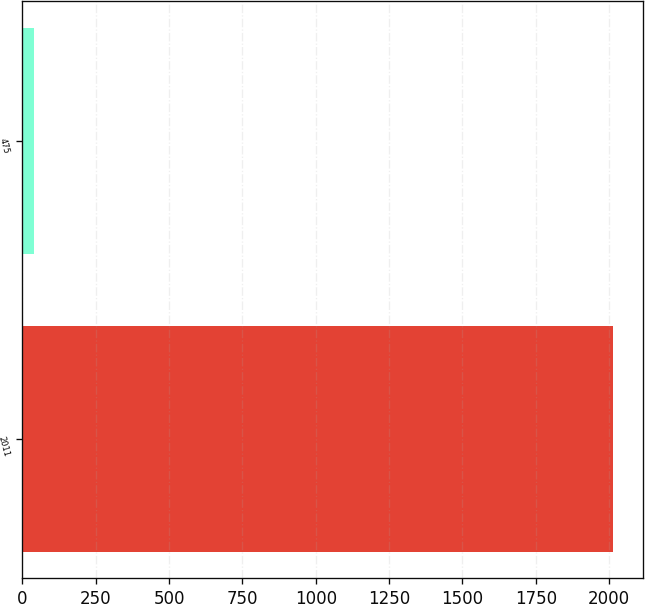Convert chart. <chart><loc_0><loc_0><loc_500><loc_500><bar_chart><fcel>2011<fcel>475<nl><fcel>2013<fcel>37.9<nl></chart> 